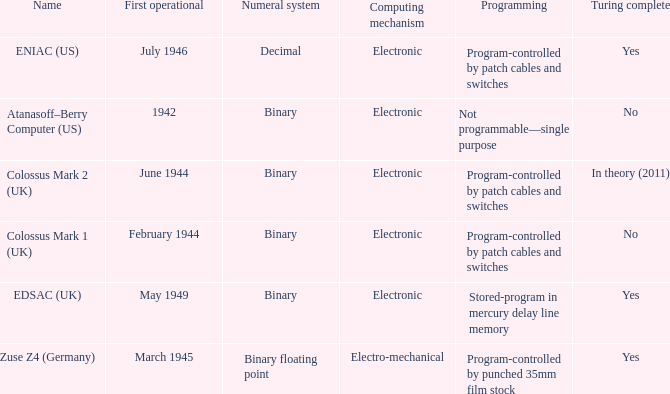What's the first operational with programming being not programmable—single purpose 1942.0. 